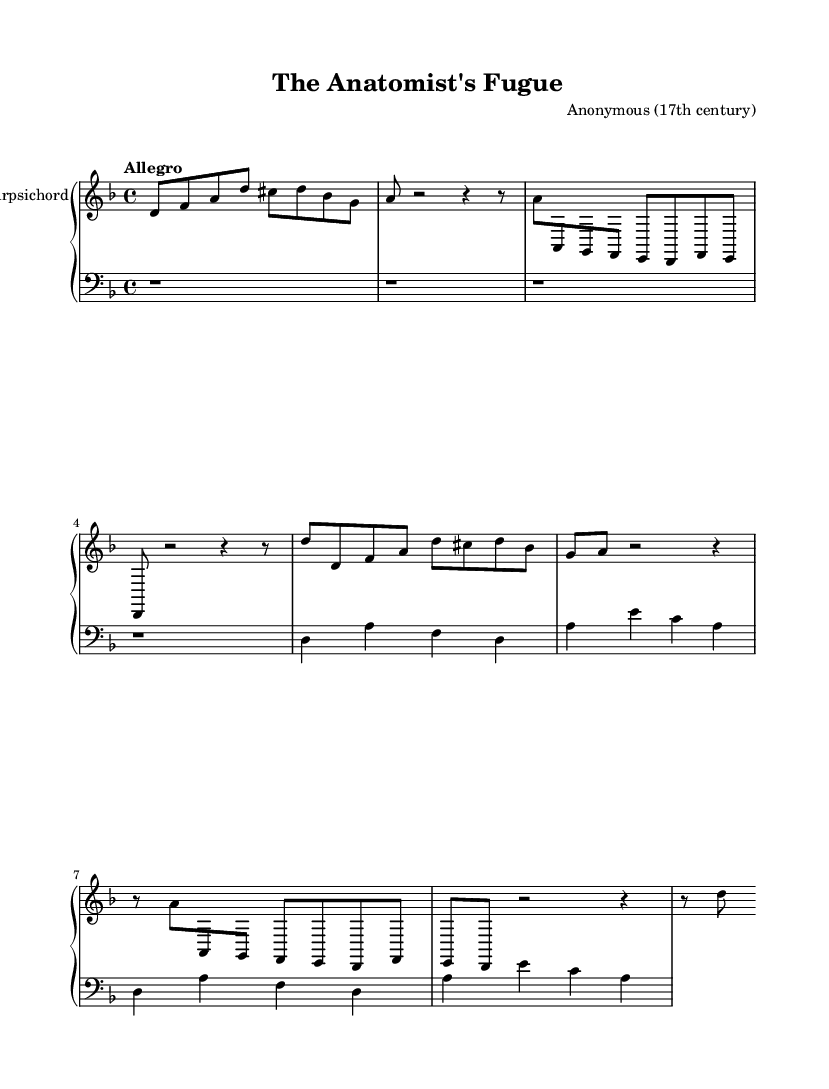What is the key signature of this music? The key signature is found at the beginning of the piece, indicating that there is one flat (B flat). This signifies D minor or F major.
Answer: D minor What is the time signature of this music? The time signature appears at the beginning as 4/4, indicating four beats per measure.
Answer: 4/4 What is the tempo marking of this piece? The tempo marking is located at the beginning of the sheet music, indicating a lively pace. It specifies "Allegro," which means fast and lively.
Answer: Allegro What is the name of the piece? The title is prominently displayed at the top of the sheet music, stating "The Anatomist's Fugue."
Answer: The Anatomist's Fugue What instrument is this music written for? The sheet music indicates at the top of the staff that the instrument is a harpsichord, which reflects the typical instrumentation of the Baroque era.
Answer: Harpsichord How many measures does the piece contain? By counting the measures visually on the staff, we can see there are a total of eight measures in the upper part.
Answer: Eight What style of music does this piece represent? This piece is identified as a fugue, a common form in Baroque music characterized by interweaving melodies, particularly evident in the subject and counter-subject sections.
Answer: Fugue 